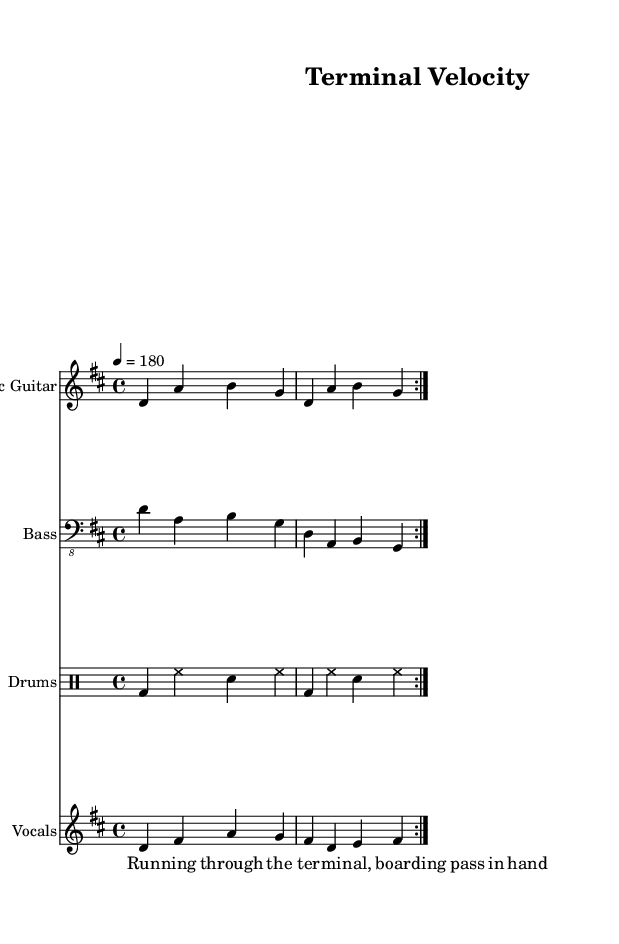What is the key signature of this music? The key signature is D major, which has two sharps (F# and C#). The key is indicated at the beginning of the staff in the sheet music.
Answer: D major What is the time signature of this music? The time signature is 4/4, meaning there are four beats in each measure and the quarter note gets one beat. This is shown at the beginning of the score.
Answer: 4/4 What is the tempo marking of the song? The tempo marking is quarter note equals 180 beats per minute, indicating a fast-paced rhythm typical of punk music. This tempo is noted at the beginning of the score.
Answer: 180 How many times is the main section repeated? The main section is repeated twice, as indicated by the "volta" markings in the electric guitar, bass, and vocals parts. Each repeat is defined within the score.
Answer: 2 What instruments are included in this music? The music includes electric guitar, bass guitar, drums, and vocals, each specified in the score with their respective staff.
Answer: Electric guitar, bass guitar, drums, vocals What lyrical theme is represented in the music? The lyrical theme revolves around rushing through an airport, indicated by the first line of the lyrics, which captures the urgency typical of punk music.
Answer: Rushing through an airport 